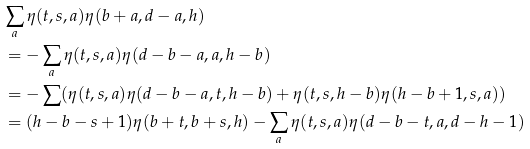Convert formula to latex. <formula><loc_0><loc_0><loc_500><loc_500>& \sum _ { a } \eta ( t , s , a ) \eta ( b + a , d - a , h ) \\ & = - \sum _ { a } \eta ( t , s , a ) \eta ( d - b - a , a , h - b ) \\ & = - \sum ( \eta ( t , s , a ) \eta ( d - b - a , t , h - b ) + \eta ( t , s , h - b ) \eta ( h - b + 1 , s , a ) ) \\ & = ( h - b - s + 1 ) \eta ( b + t , b + s , h ) - \sum _ { a } \eta ( t , s , a ) \eta ( d - b - t , a , d - h - 1 )</formula> 